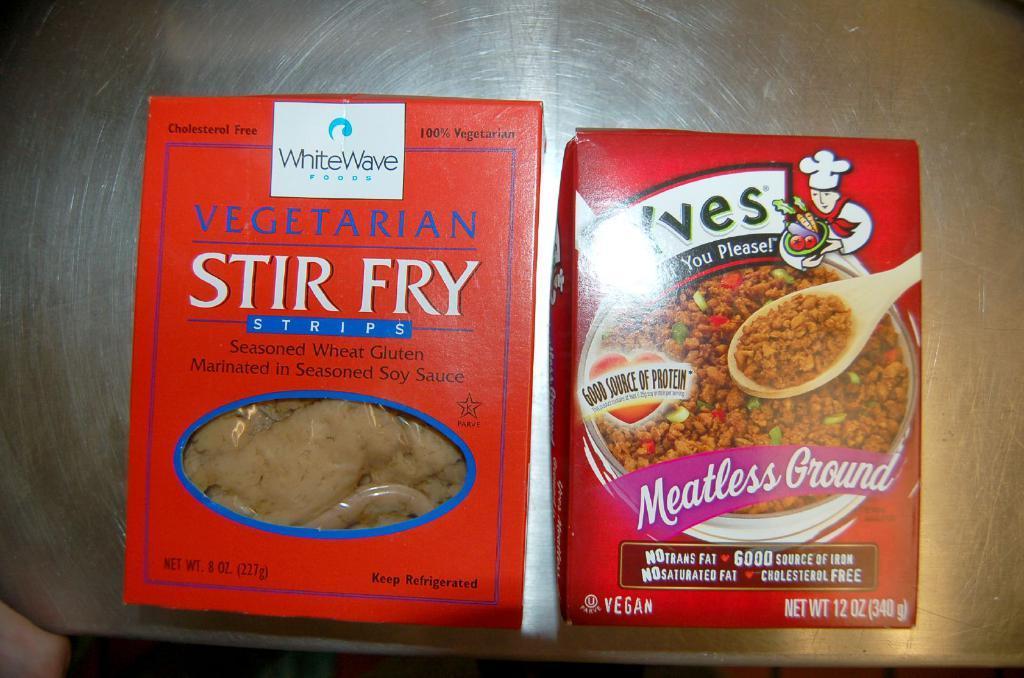Please provide a concise description of this image. In the image there are two boxes. On the left side of the image there is a box which is in red color and also there is a food item and something is written on it. On the right side of the image there is a packet which is in red color. On the packet there is an image of bowl and spoon with food items. And there is a logo on it. 